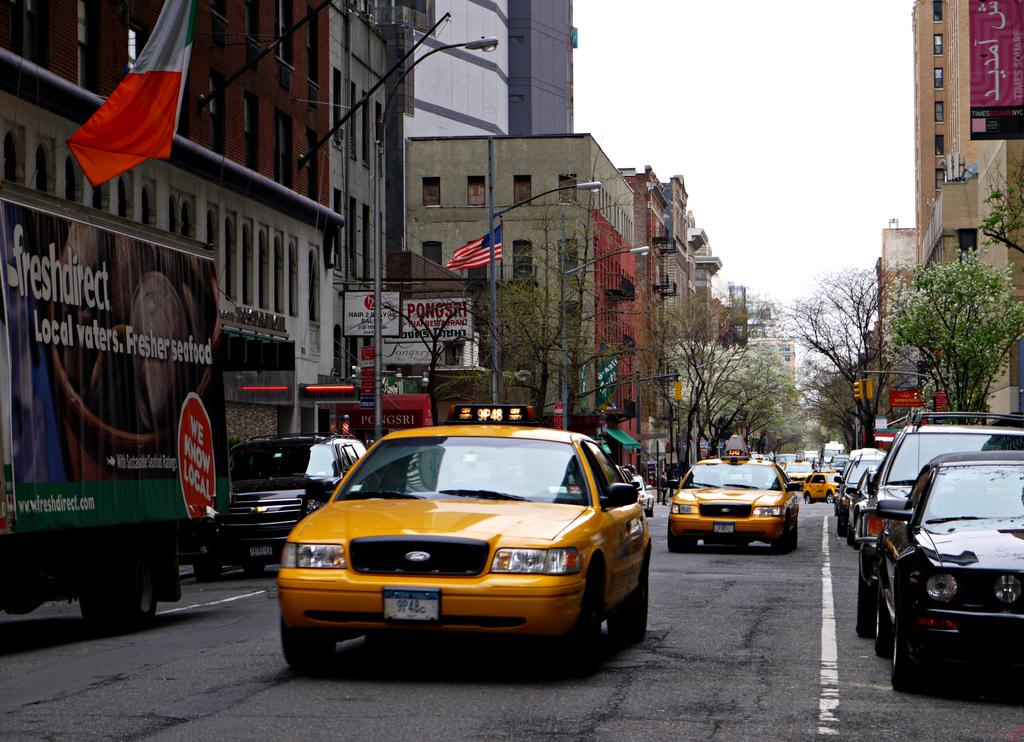<image>
Share a concise interpretation of the image provided. A freshdirect truck is next to a yellow cab. 